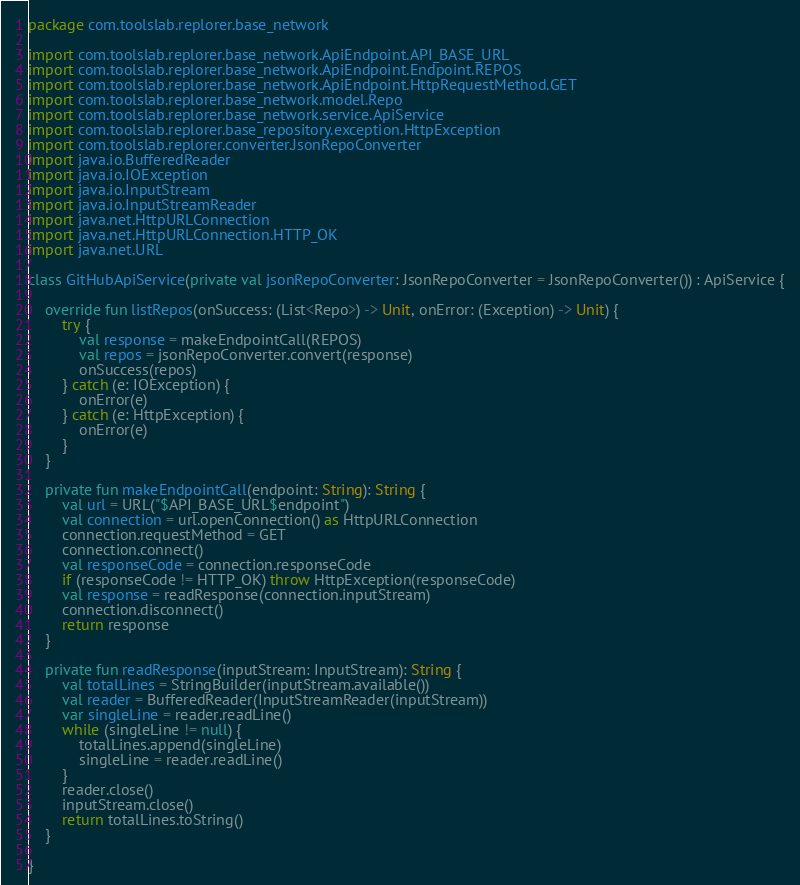Convert code to text. <code><loc_0><loc_0><loc_500><loc_500><_Kotlin_>package com.toolslab.replorer.base_network

import com.toolslab.replorer.base_network.ApiEndpoint.API_BASE_URL
import com.toolslab.replorer.base_network.ApiEndpoint.Endpoint.REPOS
import com.toolslab.replorer.base_network.ApiEndpoint.HttpRequestMethod.GET
import com.toolslab.replorer.base_network.model.Repo
import com.toolslab.replorer.base_network.service.ApiService
import com.toolslab.replorer.base_repository.exception.HttpException
import com.toolslab.replorer.converter.JsonRepoConverter
import java.io.BufferedReader
import java.io.IOException
import java.io.InputStream
import java.io.InputStreamReader
import java.net.HttpURLConnection
import java.net.HttpURLConnection.HTTP_OK
import java.net.URL

class GitHubApiService(private val jsonRepoConverter: JsonRepoConverter = JsonRepoConverter()) : ApiService {

    override fun listRepos(onSuccess: (List<Repo>) -> Unit, onError: (Exception) -> Unit) {
        try {
            val response = makeEndpointCall(REPOS)
            val repos = jsonRepoConverter.convert(response)
            onSuccess(repos)
        } catch (e: IOException) {
            onError(e)
        } catch (e: HttpException) {
            onError(e)
        }
    }

    private fun makeEndpointCall(endpoint: String): String {
        val url = URL("$API_BASE_URL$endpoint")
        val connection = url.openConnection() as HttpURLConnection
        connection.requestMethod = GET
        connection.connect()
        val responseCode = connection.responseCode
        if (responseCode != HTTP_OK) throw HttpException(responseCode)
        val response = readResponse(connection.inputStream)
        connection.disconnect()
        return response
    }

    private fun readResponse(inputStream: InputStream): String {
        val totalLines = StringBuilder(inputStream.available())
        val reader = BufferedReader(InputStreamReader(inputStream))
        var singleLine = reader.readLine()
        while (singleLine != null) {
            totalLines.append(singleLine)
            singleLine = reader.readLine()
        }
        reader.close()
        inputStream.close()
        return totalLines.toString()
    }

}
</code> 